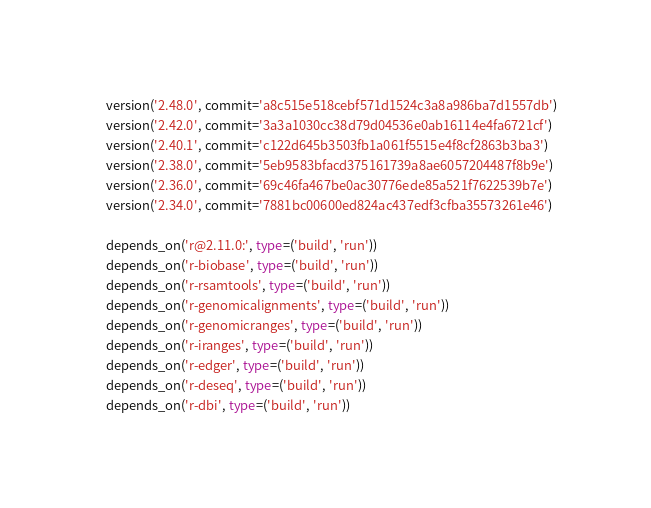Convert code to text. <code><loc_0><loc_0><loc_500><loc_500><_Python_>    version('2.48.0', commit='a8c515e518cebf571d1524c3a8a986ba7d1557db')
    version('2.42.0', commit='3a3a1030cc38d79d04536e0ab16114e4fa6721cf')
    version('2.40.1', commit='c122d645b3503fb1a061f5515e4f8cf2863b3ba3')
    version('2.38.0', commit='5eb9583bfacd375161739a8ae6057204487f8b9e')
    version('2.36.0', commit='69c46fa467be0ac30776ede85a521f7622539b7e')
    version('2.34.0', commit='7881bc00600ed824ac437edf3cfba35573261e46')

    depends_on('r@2.11.0:', type=('build', 'run'))
    depends_on('r-biobase', type=('build', 'run'))
    depends_on('r-rsamtools', type=('build', 'run'))
    depends_on('r-genomicalignments', type=('build', 'run'))
    depends_on('r-genomicranges', type=('build', 'run'))
    depends_on('r-iranges', type=('build', 'run'))
    depends_on('r-edger', type=('build', 'run'))
    depends_on('r-deseq', type=('build', 'run'))
    depends_on('r-dbi', type=('build', 'run'))
</code> 